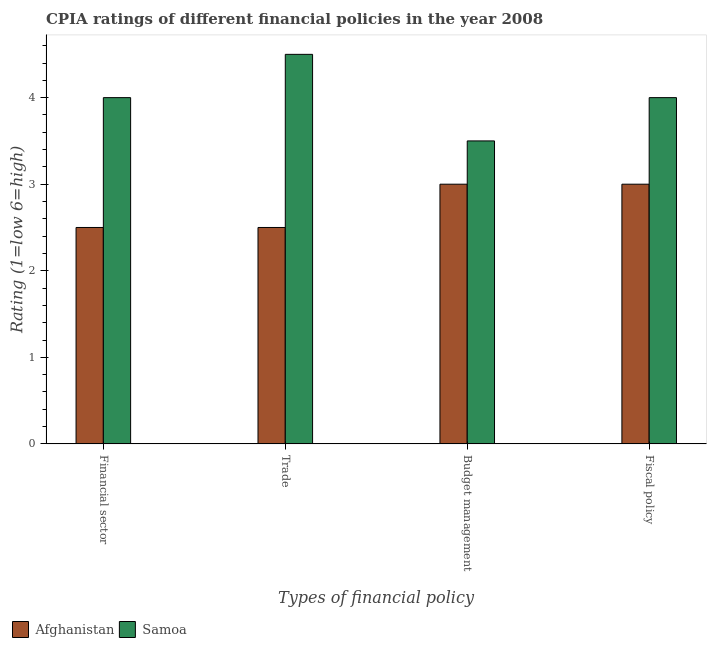Are the number of bars on each tick of the X-axis equal?
Ensure brevity in your answer.  Yes. How many bars are there on the 1st tick from the left?
Keep it short and to the point. 2. How many bars are there on the 4th tick from the right?
Give a very brief answer. 2. What is the label of the 2nd group of bars from the left?
Your answer should be compact. Trade. What is the cpia rating of budget management in Samoa?
Ensure brevity in your answer.  3.5. In which country was the cpia rating of financial sector maximum?
Provide a short and direct response. Samoa. In which country was the cpia rating of fiscal policy minimum?
Give a very brief answer. Afghanistan. What is the total cpia rating of budget management in the graph?
Your response must be concise. 6.5. What is the difference between the cpia rating of budget management in Afghanistan and that in Samoa?
Give a very brief answer. -0.5. What is the difference between the cpia rating of budget management in Samoa and the cpia rating of trade in Afghanistan?
Your answer should be compact. 1. In how many countries, is the cpia rating of budget management greater than 3.8 ?
Provide a succinct answer. 0. What is the ratio of the cpia rating of trade in Afghanistan to that in Samoa?
Give a very brief answer. 0.56. What is the difference between the highest and the second highest cpia rating of budget management?
Provide a succinct answer. 0.5. What is the difference between the highest and the lowest cpia rating of budget management?
Offer a very short reply. 0.5. Is the sum of the cpia rating of budget management in Samoa and Afghanistan greater than the maximum cpia rating of fiscal policy across all countries?
Your answer should be very brief. Yes. What does the 2nd bar from the left in Fiscal policy represents?
Ensure brevity in your answer.  Samoa. What does the 2nd bar from the right in Budget management represents?
Offer a very short reply. Afghanistan. Is it the case that in every country, the sum of the cpia rating of financial sector and cpia rating of trade is greater than the cpia rating of budget management?
Ensure brevity in your answer.  Yes. How many bars are there?
Give a very brief answer. 8. Are all the bars in the graph horizontal?
Your response must be concise. No. How many countries are there in the graph?
Give a very brief answer. 2. Are the values on the major ticks of Y-axis written in scientific E-notation?
Provide a succinct answer. No. Does the graph contain any zero values?
Offer a very short reply. No. Does the graph contain grids?
Provide a succinct answer. No. Where does the legend appear in the graph?
Ensure brevity in your answer.  Bottom left. How many legend labels are there?
Give a very brief answer. 2. What is the title of the graph?
Offer a very short reply. CPIA ratings of different financial policies in the year 2008. What is the label or title of the X-axis?
Your response must be concise. Types of financial policy. What is the label or title of the Y-axis?
Your answer should be very brief. Rating (1=low 6=high). What is the Rating (1=low 6=high) in Afghanistan in Budget management?
Your response must be concise. 3. What is the Rating (1=low 6=high) in Samoa in Budget management?
Offer a terse response. 3.5. Across all Types of financial policy, what is the minimum Rating (1=low 6=high) in Afghanistan?
Your response must be concise. 2.5. What is the difference between the Rating (1=low 6=high) of Samoa in Financial sector and that in Trade?
Your answer should be very brief. -0.5. What is the difference between the Rating (1=low 6=high) of Samoa in Financial sector and that in Budget management?
Provide a short and direct response. 0.5. What is the difference between the Rating (1=low 6=high) of Afghanistan in Financial sector and that in Fiscal policy?
Give a very brief answer. -0.5. What is the difference between the Rating (1=low 6=high) of Afghanistan in Trade and that in Budget management?
Give a very brief answer. -0.5. What is the difference between the Rating (1=low 6=high) of Afghanistan in Trade and that in Fiscal policy?
Your answer should be very brief. -0.5. What is the difference between the Rating (1=low 6=high) in Afghanistan in Budget management and that in Fiscal policy?
Your answer should be compact. 0. What is the difference between the Rating (1=low 6=high) in Afghanistan in Financial sector and the Rating (1=low 6=high) in Samoa in Budget management?
Your response must be concise. -1. What is the difference between the Rating (1=low 6=high) in Afghanistan in Financial sector and the Rating (1=low 6=high) in Samoa in Fiscal policy?
Provide a succinct answer. -1.5. What is the difference between the Rating (1=low 6=high) of Afghanistan in Trade and the Rating (1=low 6=high) of Samoa in Budget management?
Offer a terse response. -1. What is the difference between the Rating (1=low 6=high) in Afghanistan in Trade and the Rating (1=low 6=high) in Samoa in Fiscal policy?
Keep it short and to the point. -1.5. What is the difference between the Rating (1=low 6=high) in Afghanistan in Budget management and the Rating (1=low 6=high) in Samoa in Fiscal policy?
Your answer should be very brief. -1. What is the average Rating (1=low 6=high) in Afghanistan per Types of financial policy?
Your answer should be very brief. 2.75. What is the average Rating (1=low 6=high) of Samoa per Types of financial policy?
Your answer should be very brief. 4. What is the difference between the Rating (1=low 6=high) of Afghanistan and Rating (1=low 6=high) of Samoa in Financial sector?
Give a very brief answer. -1.5. What is the difference between the Rating (1=low 6=high) of Afghanistan and Rating (1=low 6=high) of Samoa in Fiscal policy?
Make the answer very short. -1. What is the ratio of the Rating (1=low 6=high) in Samoa in Financial sector to that in Trade?
Keep it short and to the point. 0.89. What is the ratio of the Rating (1=low 6=high) in Afghanistan in Financial sector to that in Budget management?
Ensure brevity in your answer.  0.83. What is the ratio of the Rating (1=low 6=high) of Afghanistan in Financial sector to that in Fiscal policy?
Your answer should be compact. 0.83. What is the ratio of the Rating (1=low 6=high) of Samoa in Financial sector to that in Fiscal policy?
Make the answer very short. 1. What is the ratio of the Rating (1=low 6=high) of Afghanistan in Trade to that in Budget management?
Keep it short and to the point. 0.83. What is the ratio of the Rating (1=low 6=high) in Afghanistan in Trade to that in Fiscal policy?
Your response must be concise. 0.83. What is the ratio of the Rating (1=low 6=high) of Samoa in Trade to that in Fiscal policy?
Give a very brief answer. 1.12. What is the ratio of the Rating (1=low 6=high) in Afghanistan in Budget management to that in Fiscal policy?
Make the answer very short. 1. What is the ratio of the Rating (1=low 6=high) of Samoa in Budget management to that in Fiscal policy?
Keep it short and to the point. 0.88. What is the difference between the highest and the second highest Rating (1=low 6=high) in Afghanistan?
Offer a terse response. 0. What is the difference between the highest and the lowest Rating (1=low 6=high) in Samoa?
Your response must be concise. 1. 